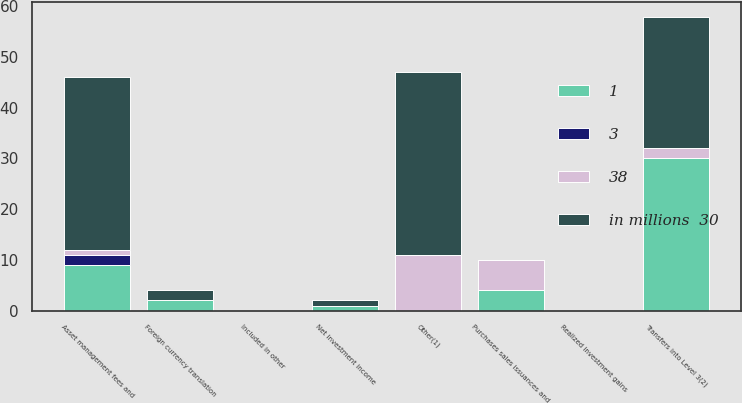Convert chart. <chart><loc_0><loc_0><loc_500><loc_500><stacked_bar_chart><ecel><fcel>Realized investment gains<fcel>Asset management fees and<fcel>Included in other<fcel>Net investment income<fcel>Purchases sales issuances and<fcel>Foreign currency translation<fcel>Other(1)<fcel>Transfers into Level 3(2)<nl><fcel>3<fcel>0<fcel>2<fcel>0<fcel>0<fcel>0<fcel>0<fcel>0<fcel>0<nl><fcel>38<fcel>0<fcel>1<fcel>0<fcel>0<fcel>6<fcel>0<fcel>11<fcel>2<nl><fcel>in millions  30<fcel>0<fcel>34<fcel>0<fcel>1<fcel>0<fcel>2<fcel>36<fcel>26<nl><fcel>1<fcel>0<fcel>9<fcel>0<fcel>1<fcel>4<fcel>2<fcel>0<fcel>30<nl></chart> 